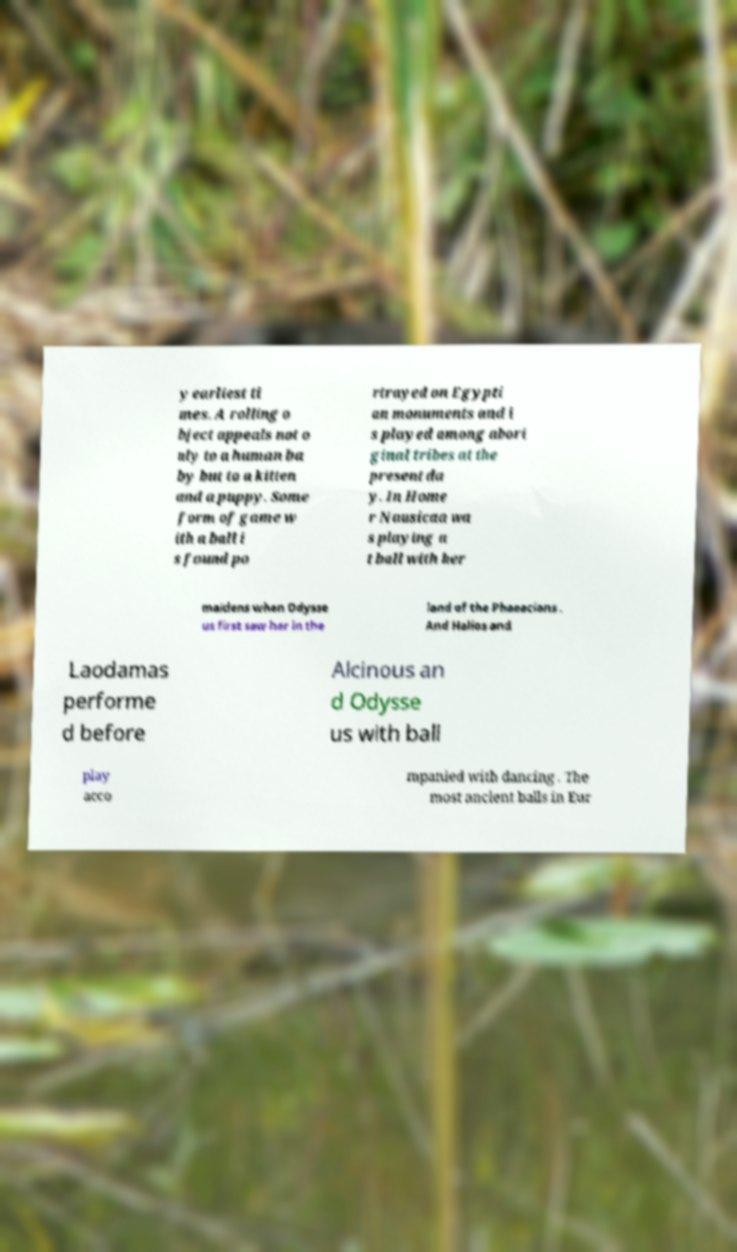Can you read and provide the text displayed in the image?This photo seems to have some interesting text. Can you extract and type it out for me? y earliest ti mes. A rolling o bject appeals not o nly to a human ba by but to a kitten and a puppy. Some form of game w ith a ball i s found po rtrayed on Egypti an monuments and i s played among abori ginal tribes at the present da y. In Home r Nausicaa wa s playing a t ball with her maidens when Odysse us first saw her in the land of the Phaeacians . And Halios and Laodamas performe d before Alcinous an d Odysse us with ball play acco mpanied with dancing . The most ancient balls in Eur 